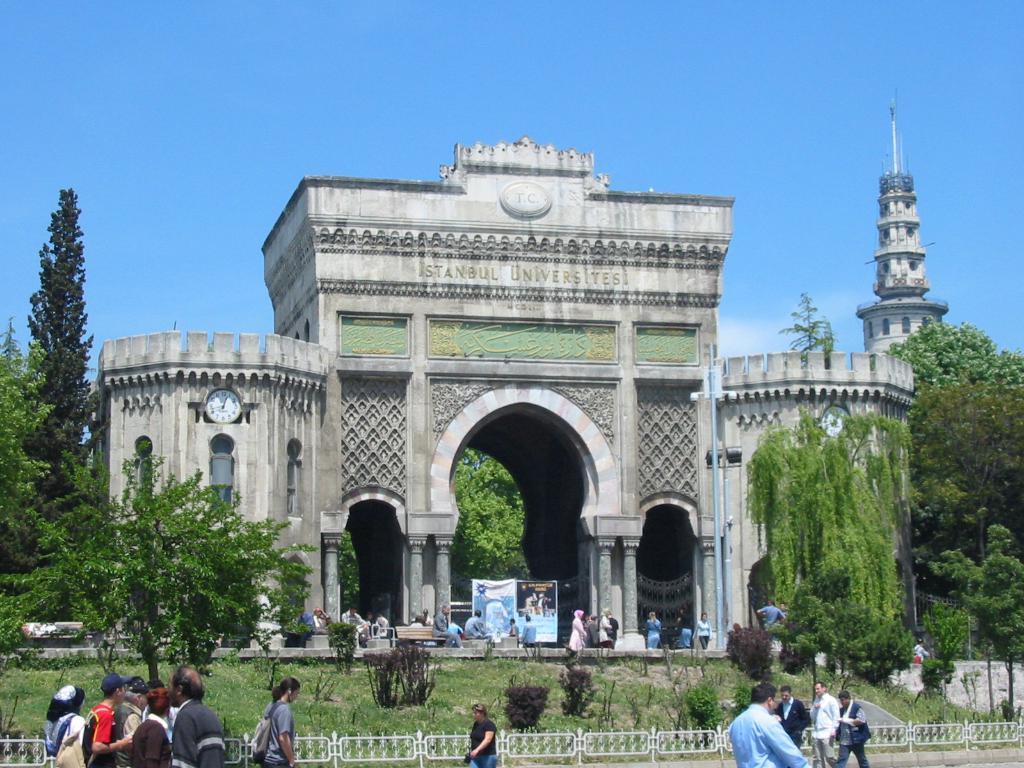Describe this image in one or two sentences. In this image there is a monument in front of the monument there are people sitting on benches and some people are walking on path, there are trees in front of the trees people are walking on road, in the background there is a sky. 